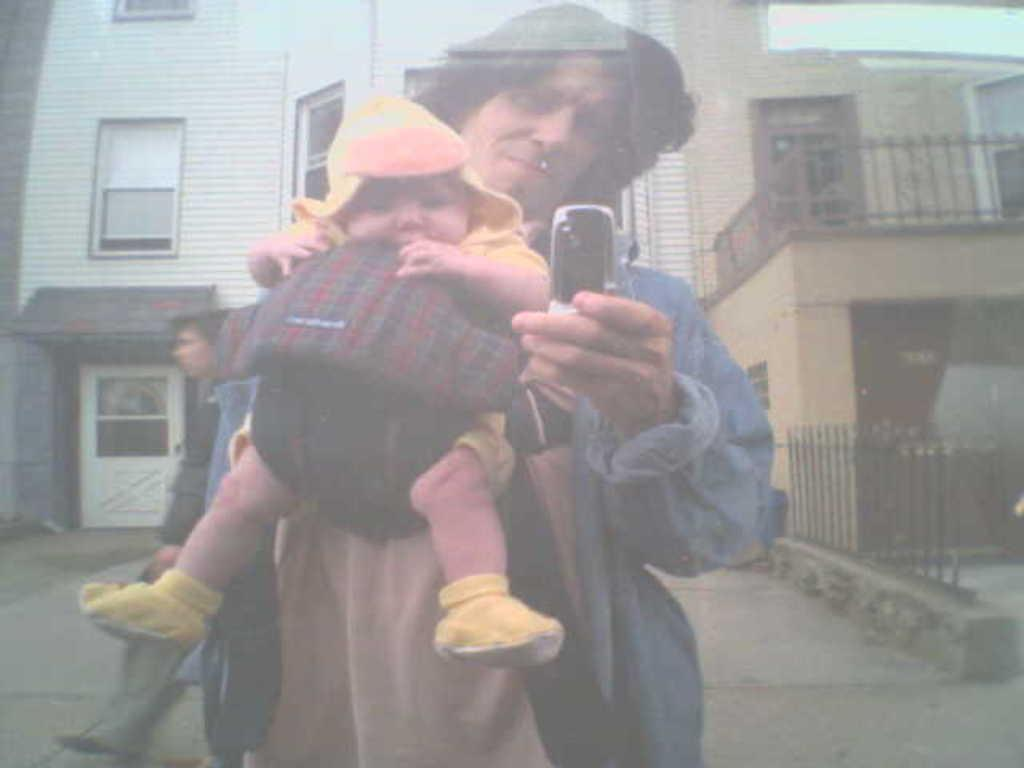What is the man in the image doing with the baby? The man is carrying a baby in the image. What object is the man holding in his hand? The man is holding a mobile in his hand. Can you describe the person walking on the left side of the image? There is another man walking on the left side of the image. What can be seen in the distance behind the people? There are buildings visible in the background of the image. Where is the ant carrying the sack in the image? There is no ant or sack present in the image. 